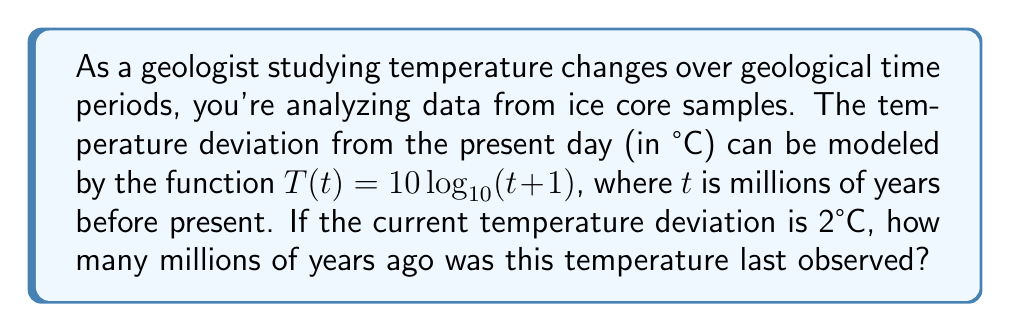What is the answer to this math problem? Let's approach this step-by-step:

1) We're given the function $T(t) = 10 \log_{10}(t+1)$, where:
   - $T$ is the temperature deviation in °C
   - $t$ is time in millions of years before present

2) We need to find $t$ when $T = 2°C$. So, let's set up the equation:

   $2 = 10 \log_{10}(t+1)$

3) Divide both sides by 10:

   $\frac{2}{10} = \log_{10}(t+1)$

4) Simplify:

   $0.2 = \log_{10}(t+1)$

5) To solve for $t$, we need to apply the inverse function (exponential) to both sides:

   $10^{0.2} = t+1$

6) Calculate $10^{0.2}$:

   $10^{0.2} \approx 1.5849$

7) Subtract 1 from both sides to isolate $t$:

   $t \approx 1.5849 - 1 = 0.5849$

8) Round to three decimal places:

   $t \approx 0.585$

Therefore, the temperature was last 2°C above present levels approximately 0.585 million years ago.
Answer: 0.585 million years ago 